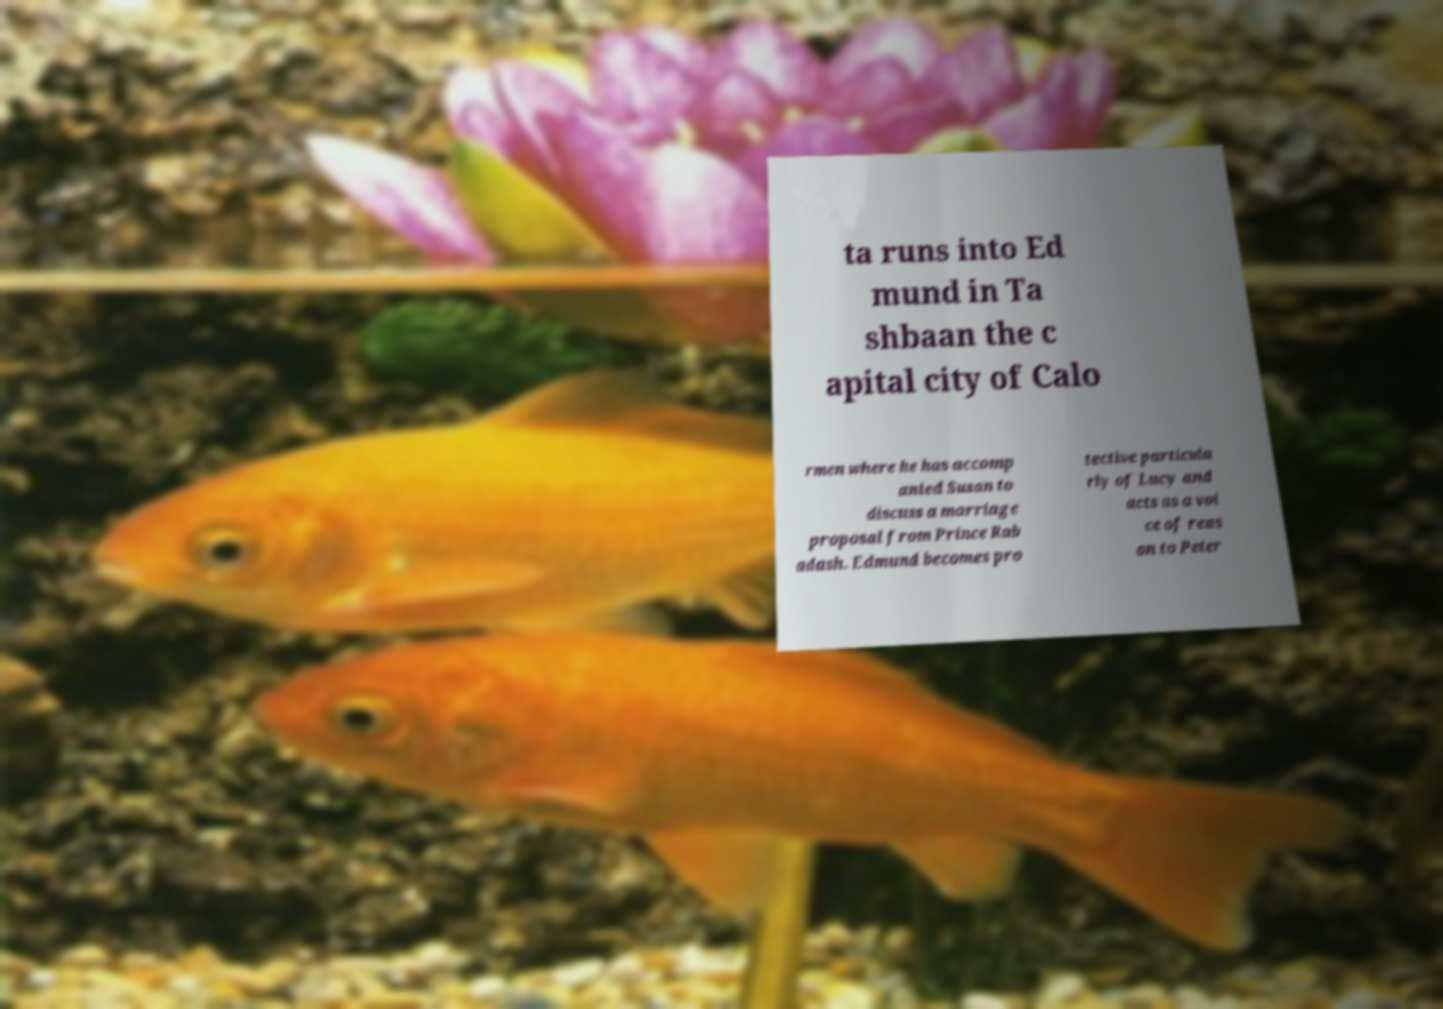What messages or text are displayed in this image? I need them in a readable, typed format. ta runs into Ed mund in Ta shbaan the c apital city of Calo rmen where he has accomp anied Susan to discuss a marriage proposal from Prince Rab adash. Edmund becomes pro tective particula rly of Lucy and acts as a voi ce of reas on to Peter 